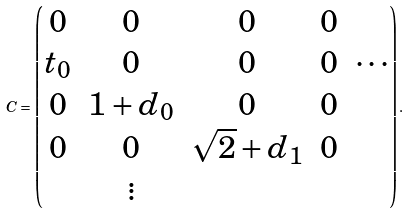Convert formula to latex. <formula><loc_0><loc_0><loc_500><loc_500>C = \begin{pmatrix} 0 & 0 & 0 & 0 & \\ t _ { 0 } & 0 & 0 & 0 & \cdots \\ 0 & 1 + d _ { 0 } & 0 & 0 & \\ 0 & 0 & \sqrt { 2 } + d _ { 1 } & 0 & \\ & \vdots & & & \end{pmatrix} .</formula> 